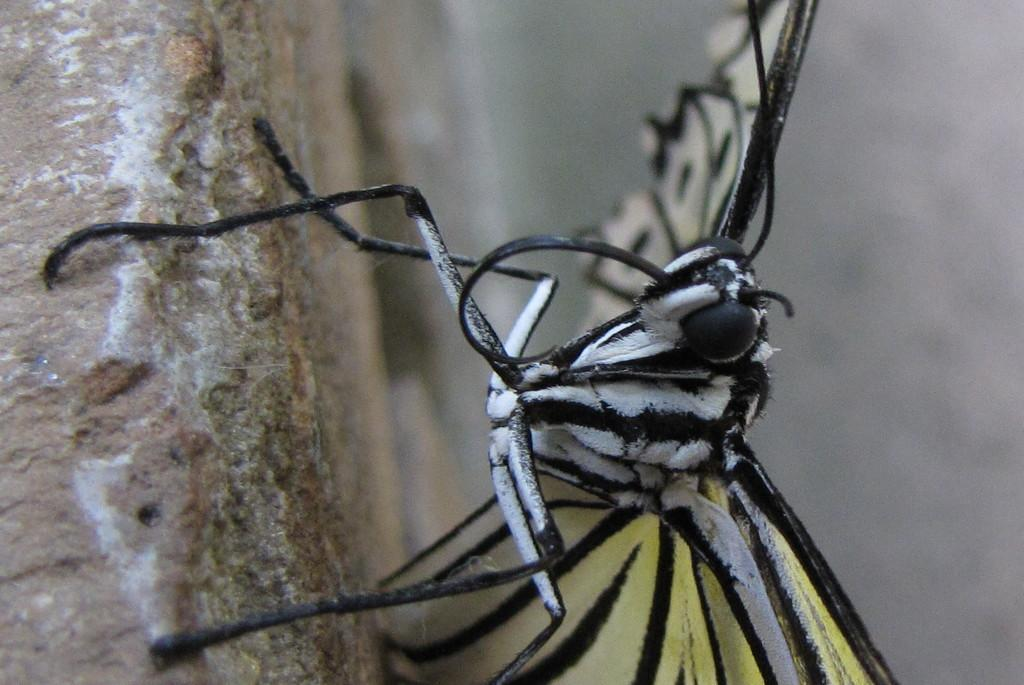What is the main subject of the image? There is a butterfly in the image. Can you describe the colors of the butterfly? The butterfly has black, white, and yellow colors. How would you describe the background of the image? The background of the image is blurry. Where is the zipper located on the butterfly in the image? There is no zipper present on the butterfly in the image, as butterflies do not have zippers. 